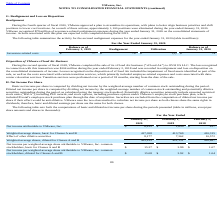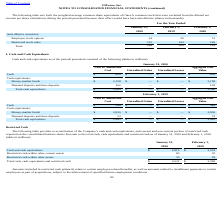From Vmware's financial document, Which years does the table provide information for the weighted-average common share equivalents of Class A common stock that were excluded from the diluted net income per share calculations? The document contains multiple relevant values: 2020, 2019, 2018. From the document: "February 1, 2019 Realignment Utilization During the fourth quarter of fiscal 2020, VMware approved a plan to streamline its operations, with plans to ..." Also, What was the Employee stock options in 2019? According to the financial document, 50 (in thousands). The relevant text states: "Employee stock options 34 50 51..." Also, What were the Restricted stock units in 2018? According to the financial document, 140 (in thousands). The relevant text states: "Restricted stock units 315 255 140..." Also, can you calculate: What was the change in employee stock options between 2018 and 2019? Based on the calculation: 50-51, the result is -1 (in thousands). This is based on the information: "Employee stock options 34 50 51 Employee stock options 34 50 51..." The key data points involved are: 50, 51. Also, How many years did Restricted stock units exceed $200 thousand? Counting the relevant items in the document: 2020, 2019, I find 2 instances. The key data points involved are: 2019, 2020. Also, can you calculate: What was the percentage change in the total anti-dilutive securities between 2019 and 2020? To answer this question, I need to perform calculations using the financial data. The calculation is: (349-305)/305, which equals 14.43 (percentage). This is based on the information: "Total 349 305 191 Total 349 305 191..." The key data points involved are: 305, 349. 